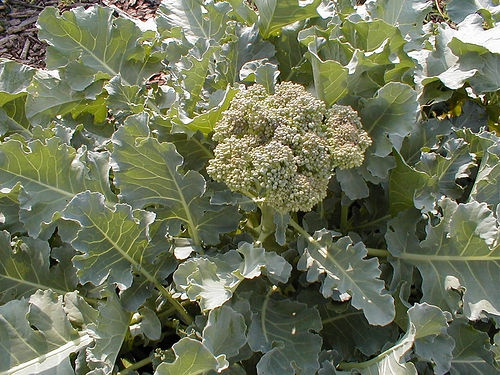Describe the objects in this image and their specific colors. I can see a broccoli in navy, olive, gray, and ivory tones in this image. 